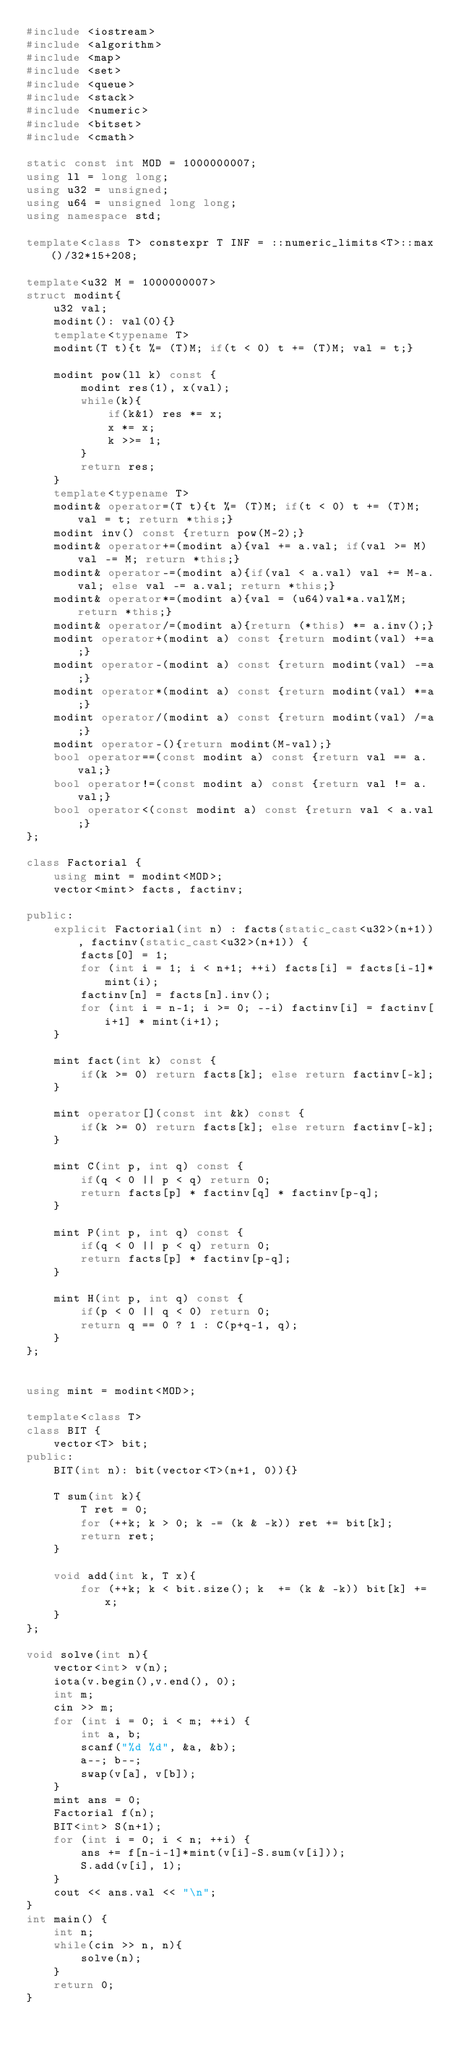Convert code to text. <code><loc_0><loc_0><loc_500><loc_500><_C++_>#include <iostream>
#include <algorithm>
#include <map>
#include <set>
#include <queue>
#include <stack>
#include <numeric>
#include <bitset>
#include <cmath>

static const int MOD = 1000000007;
using ll = long long;
using u32 = unsigned;
using u64 = unsigned long long;
using namespace std;

template<class T> constexpr T INF = ::numeric_limits<T>::max()/32*15+208;

template<u32 M = 1000000007>
struct modint{
    u32 val;
    modint(): val(0){}
    template<typename T>
    modint(T t){t %= (T)M; if(t < 0) t += (T)M; val = t;}

    modint pow(ll k) const {
        modint res(1), x(val);
        while(k){
            if(k&1) res *= x;
            x *= x;
            k >>= 1;
        }
        return res;
    }
    template<typename T>
    modint& operator=(T t){t %= (T)M; if(t < 0) t += (T)M; val = t; return *this;}
    modint inv() const {return pow(M-2);}
    modint& operator+=(modint a){val += a.val; if(val >= M) val -= M; return *this;}
    modint& operator-=(modint a){if(val < a.val) val += M-a.val; else val -= a.val; return *this;}
    modint& operator*=(modint a){val = (u64)val*a.val%M; return *this;}
    modint& operator/=(modint a){return (*this) *= a.inv();}
    modint operator+(modint a) const {return modint(val) +=a;}
    modint operator-(modint a) const {return modint(val) -=a;}
    modint operator*(modint a) const {return modint(val) *=a;}
    modint operator/(modint a) const {return modint(val) /=a;}
    modint operator-(){return modint(M-val);}
    bool operator==(const modint a) const {return val == a.val;}
    bool operator!=(const modint a) const {return val != a.val;}
    bool operator<(const modint a) const {return val < a.val;}
};

class Factorial {
    using mint = modint<MOD>;
    vector<mint> facts, factinv;

public:
    explicit Factorial(int n) : facts(static_cast<u32>(n+1)), factinv(static_cast<u32>(n+1)) {
        facts[0] = 1;
        for (int i = 1; i < n+1; ++i) facts[i] = facts[i-1]*mint(i);
        factinv[n] = facts[n].inv();
        for (int i = n-1; i >= 0; --i) factinv[i] = factinv[i+1] * mint(i+1);
    }

    mint fact(int k) const {
        if(k >= 0) return facts[k]; else return factinv[-k];
    }

    mint operator[](const int &k) const {
        if(k >= 0) return facts[k]; else return factinv[-k];
    }

    mint C(int p, int q) const {
        if(q < 0 || p < q) return 0;
        return facts[p] * factinv[q] * factinv[p-q];
    }

    mint P(int p, int q) const {
        if(q < 0 || p < q) return 0;
        return facts[p] * factinv[p-q];
    }

    mint H(int p, int q) const {
        if(p < 0 || q < 0) return 0;
        return q == 0 ? 1 : C(p+q-1, q);
    }
};


using mint = modint<MOD>;

template<class T>
class BIT {
    vector<T> bit;
public:
    BIT(int n): bit(vector<T>(n+1, 0)){}

    T sum(int k){
        T ret = 0;
        for (++k; k > 0; k -= (k & -k)) ret += bit[k];
        return ret;
    }

    void add(int k, T x){
        for (++k; k < bit.size(); k  += (k & -k)) bit[k] += x;
    }
};

void solve(int n){
    vector<int> v(n);
    iota(v.begin(),v.end(), 0);
    int m;
    cin >> m;
    for (int i = 0; i < m; ++i) {
        int a, b;
        scanf("%d %d", &a, &b);
        a--; b--;
        swap(v[a], v[b]);
    }
    mint ans = 0;
    Factorial f(n);
    BIT<int> S(n+1);
    for (int i = 0; i < n; ++i) {
        ans += f[n-i-1]*mint(v[i]-S.sum(v[i]));
        S.add(v[i], 1);
    }
    cout << ans.val << "\n";
}
int main() {
    int n;
    while(cin >> n, n){
        solve(n);
    }
    return 0;
}
</code> 